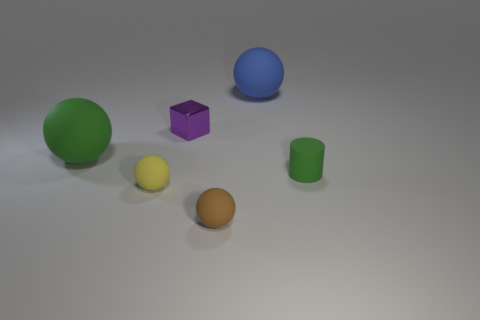What number of blocks are either large brown objects or small shiny things?
Ensure brevity in your answer.  1. There is a small ball on the left side of the small brown rubber object; does it have the same color as the cylinder?
Your answer should be compact. No. There is a big ball on the right side of the small brown rubber object that is to the left of the green matte object that is on the right side of the big blue matte object; what is its material?
Your response must be concise. Rubber. Do the green ball and the brown sphere have the same size?
Your answer should be very brief. No. There is a tiny metal block; does it have the same color as the big sphere to the left of the small brown sphere?
Keep it short and to the point. No. What is the shape of the small brown object that is the same material as the tiny yellow ball?
Offer a very short reply. Sphere. Is the shape of the green rubber object on the right side of the big blue ball the same as  the tiny metal object?
Provide a succinct answer. No. There is a green object left of the small matte object that is right of the big blue object; how big is it?
Give a very brief answer. Large. There is a cylinder that is the same material as the big blue ball; what is its color?
Your response must be concise. Green. What number of green matte spheres are the same size as the purple metal thing?
Give a very brief answer. 0. 